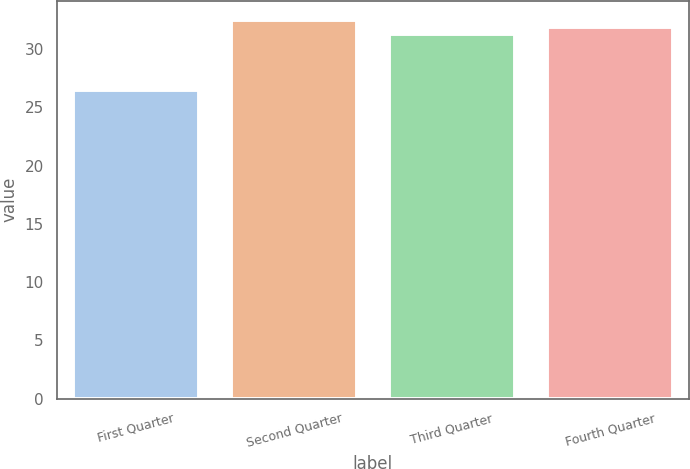Convert chart. <chart><loc_0><loc_0><loc_500><loc_500><bar_chart><fcel>First Quarter<fcel>Second Quarter<fcel>Third Quarter<fcel>Fourth Quarter<nl><fcel>26.5<fcel>32.52<fcel>31.34<fcel>31.93<nl></chart> 